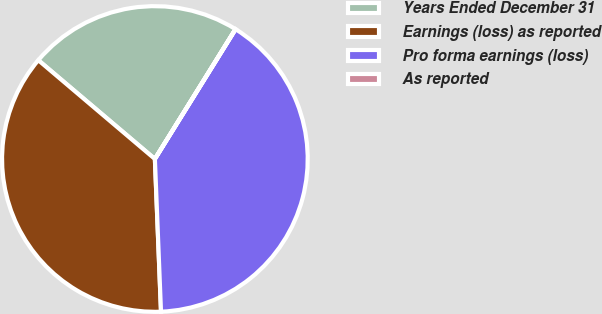Convert chart to OTSL. <chart><loc_0><loc_0><loc_500><loc_500><pie_chart><fcel>Years Ended December 31<fcel>Earnings (loss) as reported<fcel>Pro forma earnings (loss)<fcel>As reported<nl><fcel>22.65%<fcel>36.83%<fcel>40.51%<fcel>0.02%<nl></chart> 